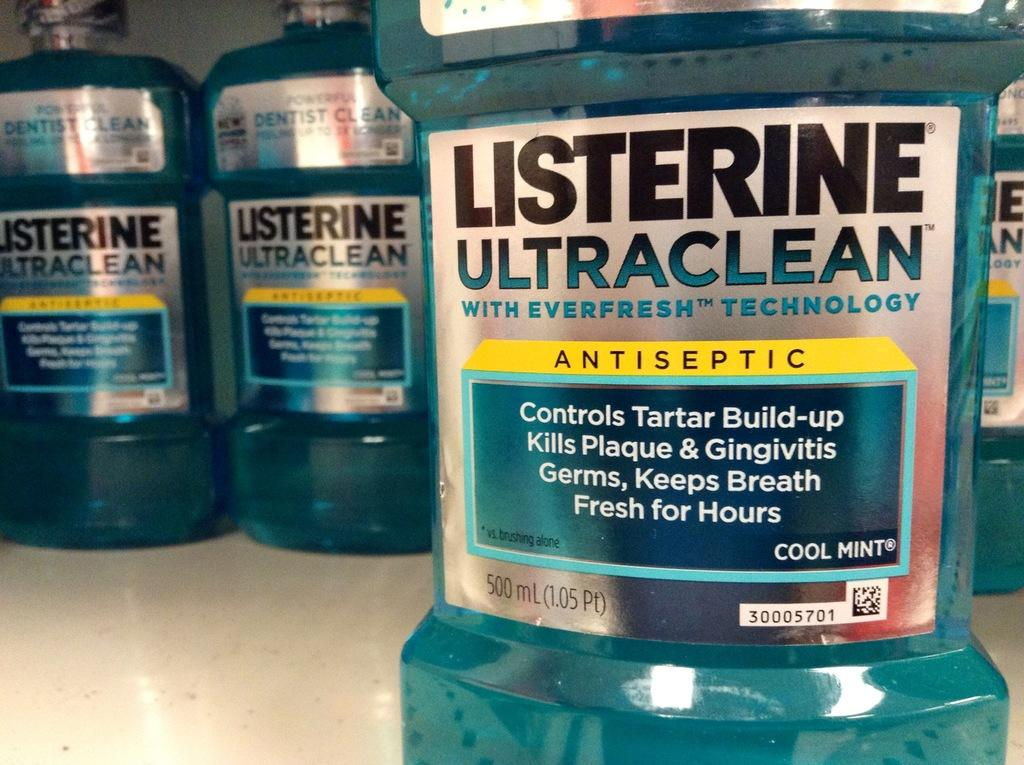Provide a one-sentence caption for the provided image. Many bottles of cool mint flavored listerine mouthwash. 